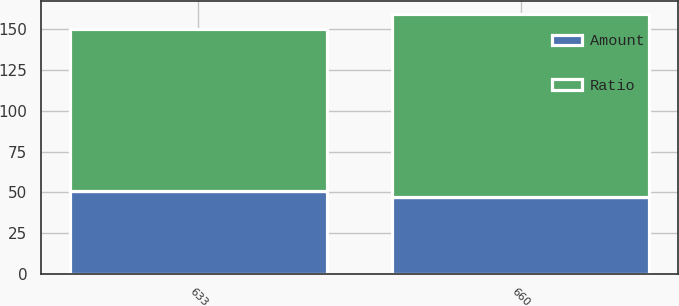Convert chart. <chart><loc_0><loc_0><loc_500><loc_500><stacked_bar_chart><ecel><fcel>660<fcel>633<nl><fcel>Ratio<fcel>112.7<fcel>99.1<nl><fcel>Amount<fcel>47<fcel>51<nl></chart> 